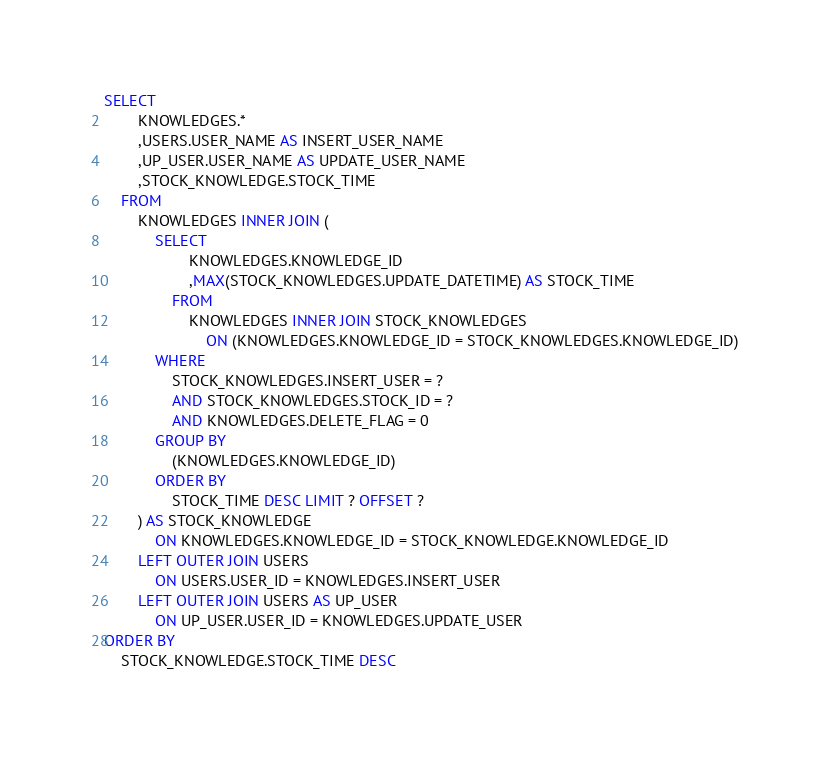Convert code to text. <code><loc_0><loc_0><loc_500><loc_500><_SQL_>SELECT
        KNOWLEDGES.*
        ,USERS.USER_NAME AS INSERT_USER_NAME
        ,UP_USER.USER_NAME AS UPDATE_USER_NAME
        ,STOCK_KNOWLEDGE.STOCK_TIME
    FROM
        KNOWLEDGES INNER JOIN (
            SELECT
                    KNOWLEDGES.KNOWLEDGE_ID
                    ,MAX(STOCK_KNOWLEDGES.UPDATE_DATETIME) AS STOCK_TIME
                FROM
                    KNOWLEDGES INNER JOIN STOCK_KNOWLEDGES
                        ON (KNOWLEDGES.KNOWLEDGE_ID = STOCK_KNOWLEDGES.KNOWLEDGE_ID)
            WHERE
                STOCK_KNOWLEDGES.INSERT_USER = ?
                AND STOCK_KNOWLEDGES.STOCK_ID = ?
                AND KNOWLEDGES.DELETE_FLAG = 0
            GROUP BY
                (KNOWLEDGES.KNOWLEDGE_ID)
            ORDER BY
                STOCK_TIME DESC LIMIT ? OFFSET ?
        ) AS STOCK_KNOWLEDGE
            ON KNOWLEDGES.KNOWLEDGE_ID = STOCK_KNOWLEDGE.KNOWLEDGE_ID
        LEFT OUTER JOIN USERS
            ON USERS.USER_ID = KNOWLEDGES.INSERT_USER
        LEFT OUTER JOIN USERS AS UP_USER
            ON UP_USER.USER_ID = KNOWLEDGES.UPDATE_USER
ORDER BY
    STOCK_KNOWLEDGE.STOCK_TIME DESC
</code> 